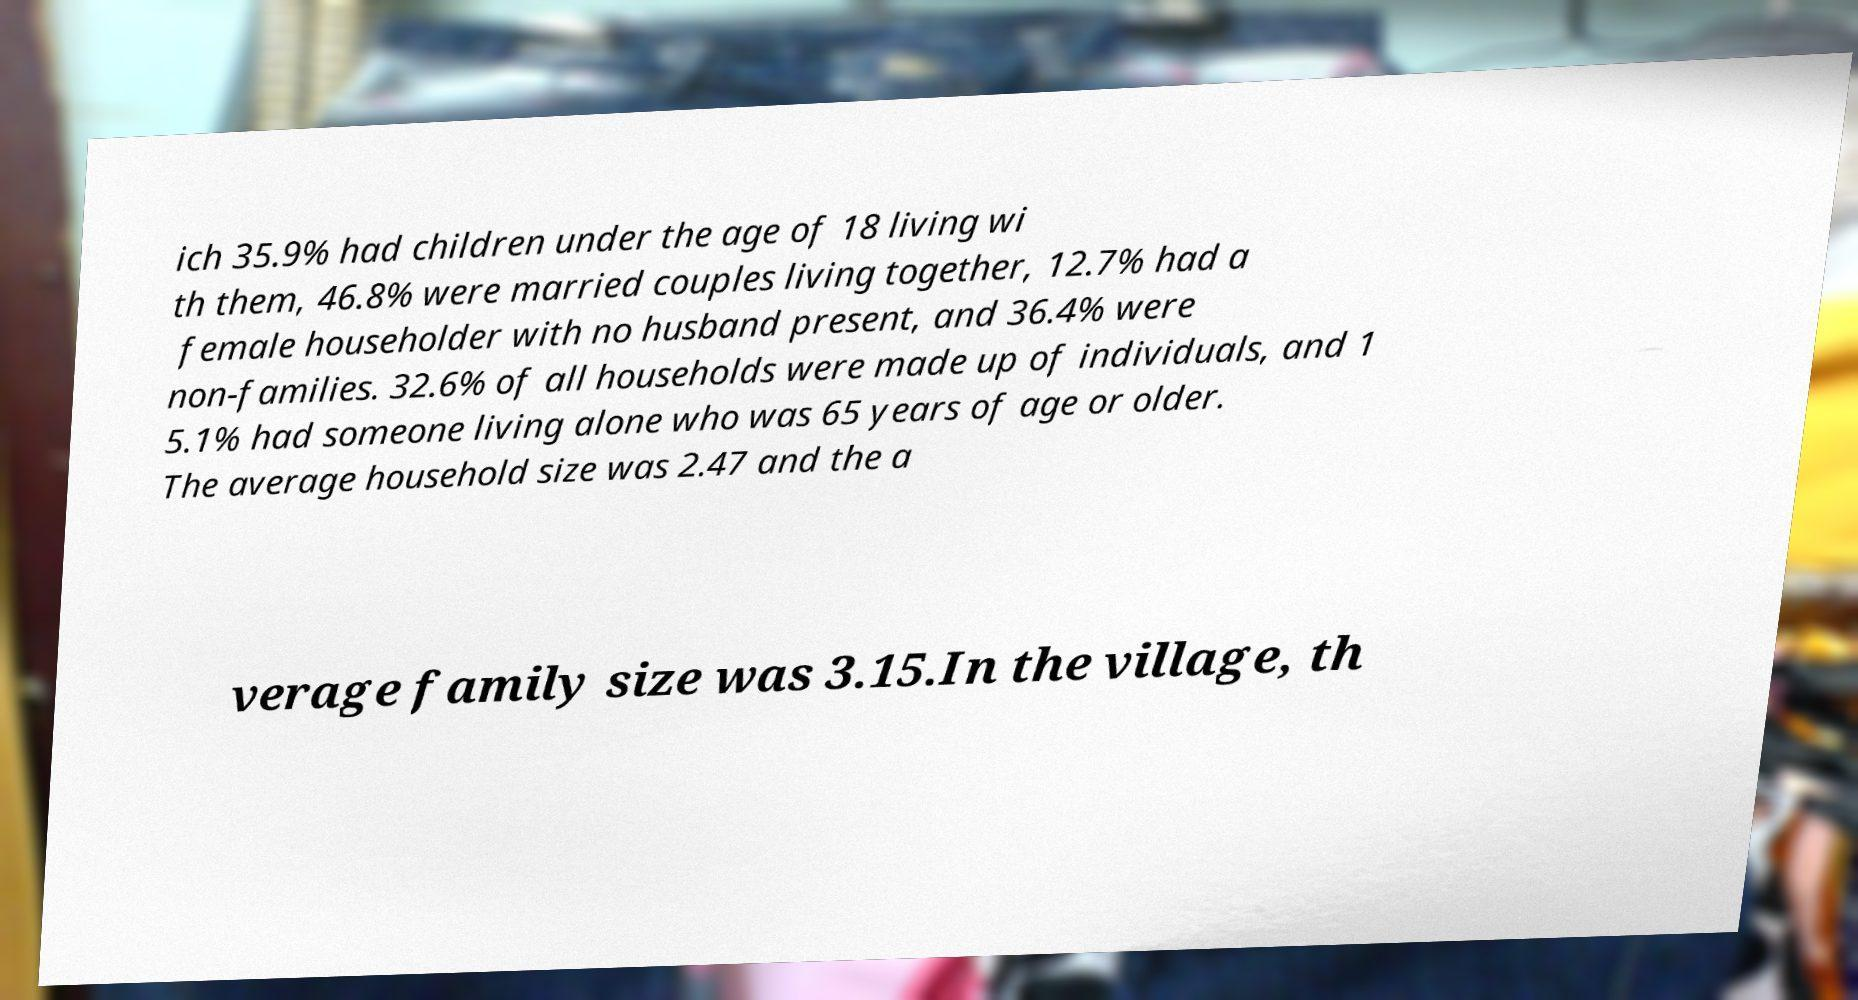For documentation purposes, I need the text within this image transcribed. Could you provide that? ich 35.9% had children under the age of 18 living wi th them, 46.8% were married couples living together, 12.7% had a female householder with no husband present, and 36.4% were non-families. 32.6% of all households were made up of individuals, and 1 5.1% had someone living alone who was 65 years of age or older. The average household size was 2.47 and the a verage family size was 3.15.In the village, th 